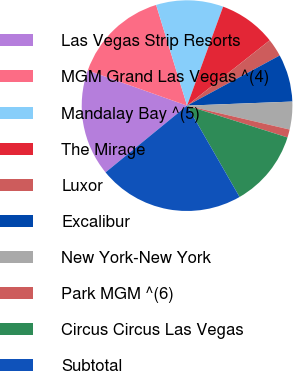Convert chart. <chart><loc_0><loc_0><loc_500><loc_500><pie_chart><fcel>Las Vegas Strip Resorts<fcel>MGM Grand Las Vegas ^(4)<fcel>Mandalay Bay ^(5)<fcel>The Mirage<fcel>Luxor<fcel>Excalibur<fcel>New York-New York<fcel>Park MGM ^(6)<fcel>Circus Circus Las Vegas<fcel>Subtotal<nl><fcel>16.34%<fcel>14.83%<fcel>10.3%<fcel>8.79%<fcel>2.75%<fcel>7.28%<fcel>4.26%<fcel>1.24%<fcel>11.81%<fcel>22.38%<nl></chart> 